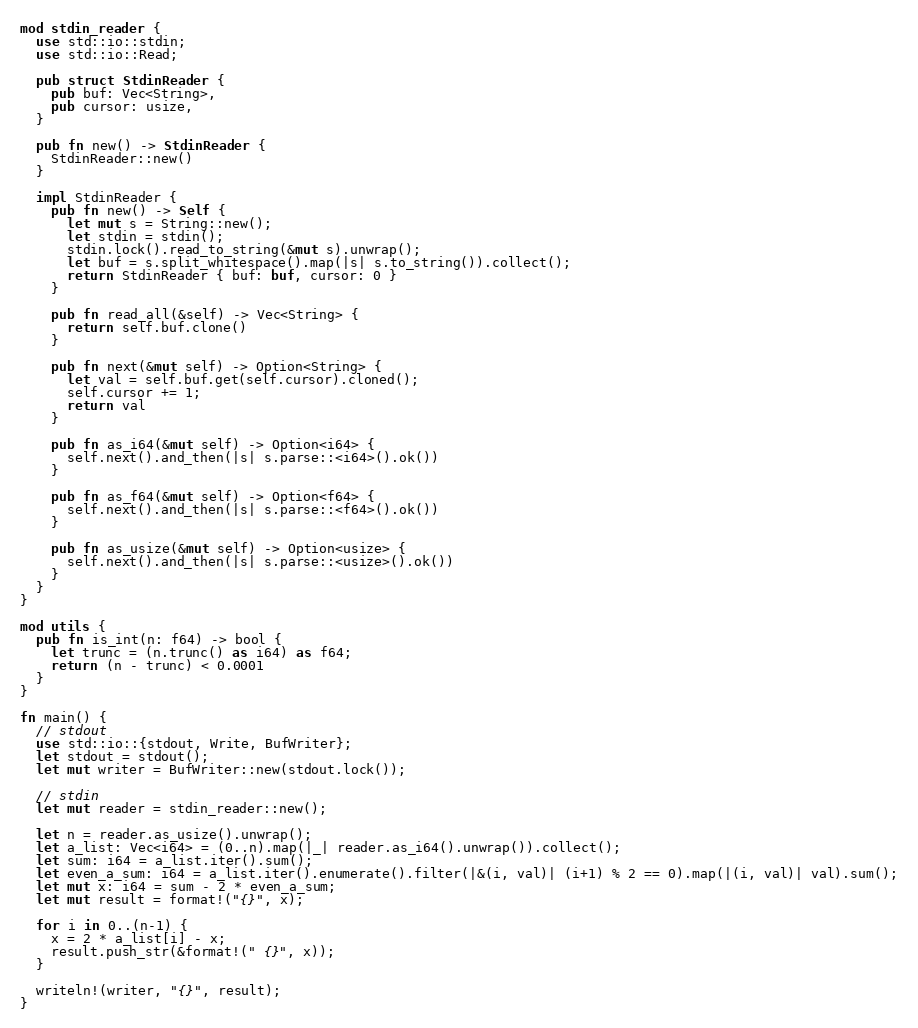<code> <loc_0><loc_0><loc_500><loc_500><_Rust_>mod stdin_reader {
  use std::io::stdin;
  use std::io::Read;

  pub struct StdinReader {
    pub buf: Vec<String>,
    pub cursor: usize,
  }

  pub fn new() -> StdinReader {
    StdinReader::new()
  }

  impl StdinReader {
    pub fn new() -> Self {
      let mut s = String::new();
      let stdin = stdin();
      stdin.lock().read_to_string(&mut s).unwrap();
      let buf = s.split_whitespace().map(|s| s.to_string()).collect();
      return StdinReader { buf: buf, cursor: 0 }
    }

    pub fn read_all(&self) -> Vec<String> {
      return self.buf.clone()
    }

    pub fn next(&mut self) -> Option<String> {
      let val = self.buf.get(self.cursor).cloned();
      self.cursor += 1;
      return val
    }

    pub fn as_i64(&mut self) -> Option<i64> {
      self.next().and_then(|s| s.parse::<i64>().ok())
    }

    pub fn as_f64(&mut self) -> Option<f64> {
      self.next().and_then(|s| s.parse::<f64>().ok())
    }

    pub fn as_usize(&mut self) -> Option<usize> {
      self.next().and_then(|s| s.parse::<usize>().ok())
    }
  }
}

mod utils {
  pub fn is_int(n: f64) -> bool {
    let trunc = (n.trunc() as i64) as f64;
    return (n - trunc) < 0.0001
  }
}

fn main() {
  // stdout
  use std::io::{stdout, Write, BufWriter};
  let stdout = stdout();
  let mut writer = BufWriter::new(stdout.lock());

  // stdin
  let mut reader = stdin_reader::new();

  let n = reader.as_usize().unwrap();
  let a_list: Vec<i64> = (0..n).map(|_| reader.as_i64().unwrap()).collect();
  let sum: i64 = a_list.iter().sum();
  let even_a_sum: i64 = a_list.iter().enumerate().filter(|&(i, val)| (i+1) % 2 == 0).map(|(i, val)| val).sum();
  let mut x: i64 = sum - 2 * even_a_sum;
  let mut result = format!("{}", x);

  for i in 0..(n-1) {
    x = 2 * a_list[i] - x;
    result.push_str(&format!(" {}", x));
  }

  writeln!(writer, "{}", result);
}</code> 